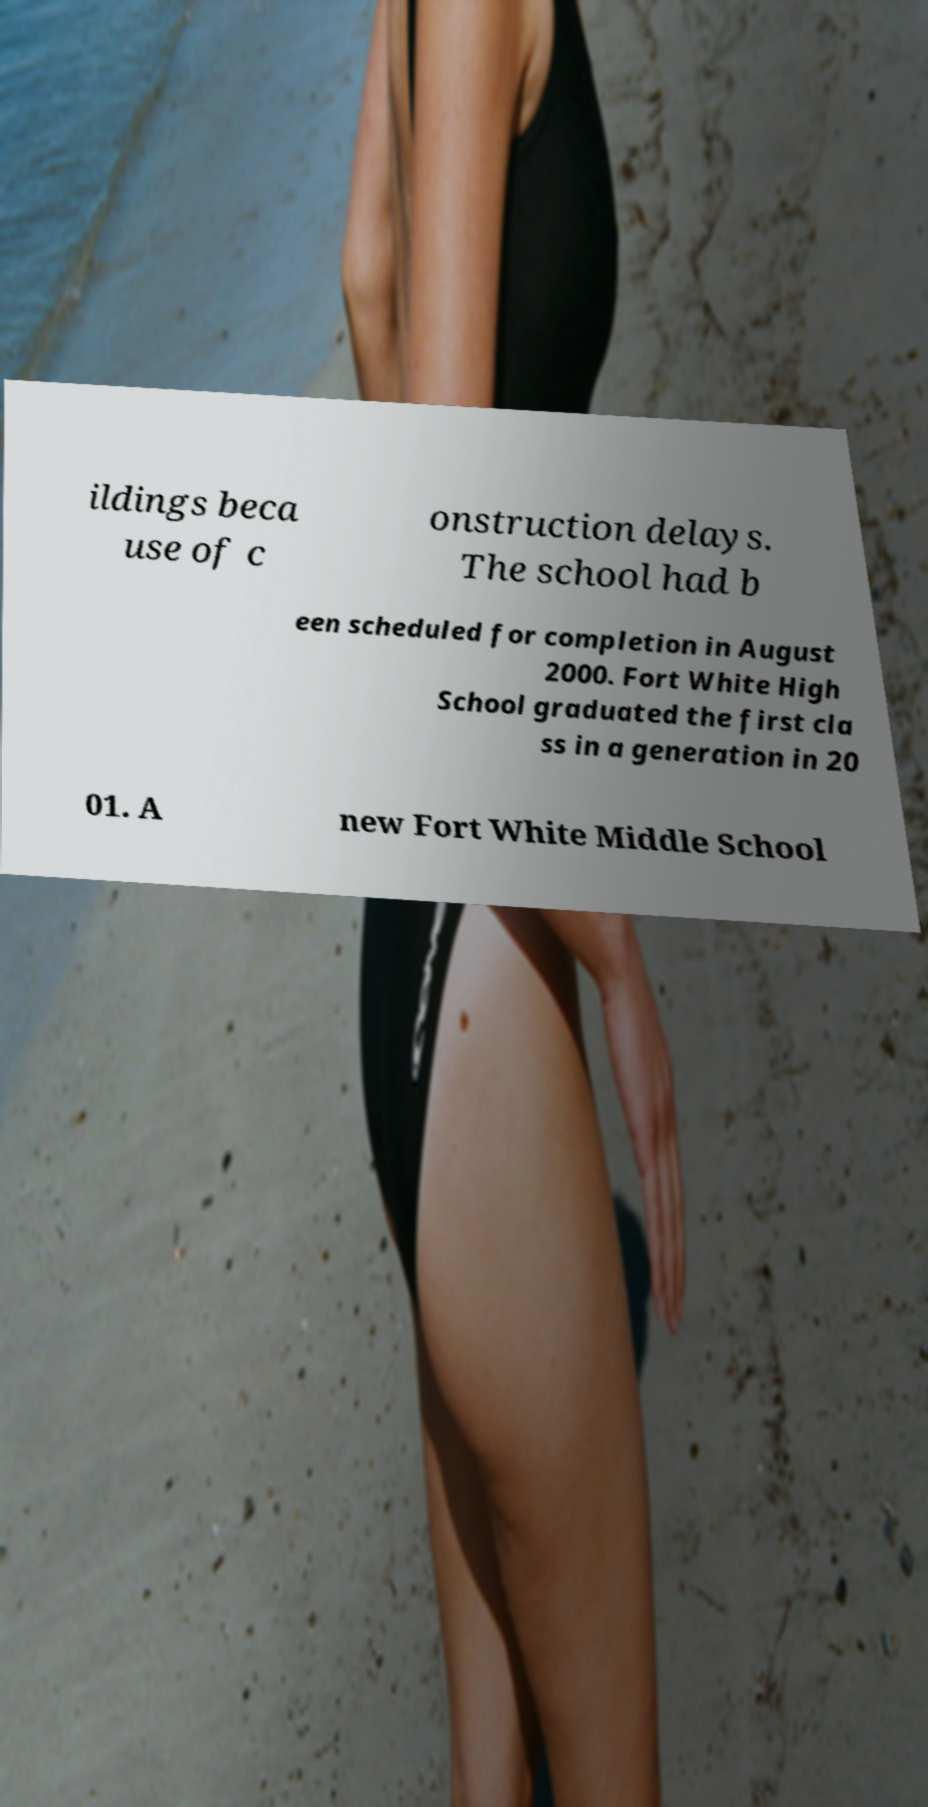For documentation purposes, I need the text within this image transcribed. Could you provide that? ildings beca use of c onstruction delays. The school had b een scheduled for completion in August 2000. Fort White High School graduated the first cla ss in a generation in 20 01. A new Fort White Middle School 